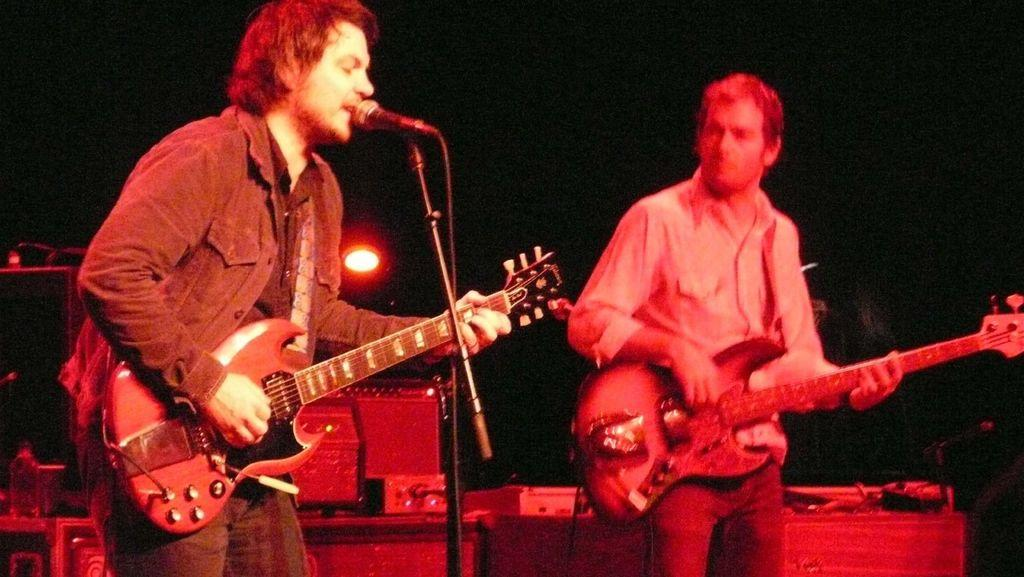How many people are in the image? There are two men in the image. What are the men doing in the image? One man is playing a guitar, and another man is singing with the help of a microphone. Is the man who is singing also playing an instrument? Yes, the man who is singing is also playing a guitar. How many houses can be seen in the image? There are no houses visible in the image; it features two men, one playing a guitar and the other singing with a microphone. What type of magic is being performed by the man with the microphone? There is no magic being performed in the image; the man is simply singing with the help of a microphone. 